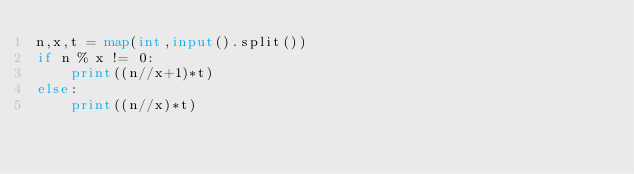Convert code to text. <code><loc_0><loc_0><loc_500><loc_500><_Python_>n,x,t = map(int,input().split())
if n % x != 0:
    print((n//x+1)*t)
else:
    print((n//x)*t)</code> 